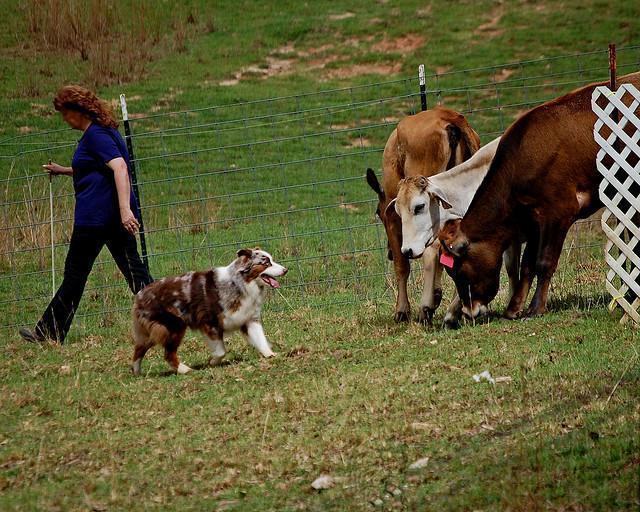How many cows are standing in front of the dog?
Give a very brief answer. 3. How many cows are there?
Give a very brief answer. 3. 